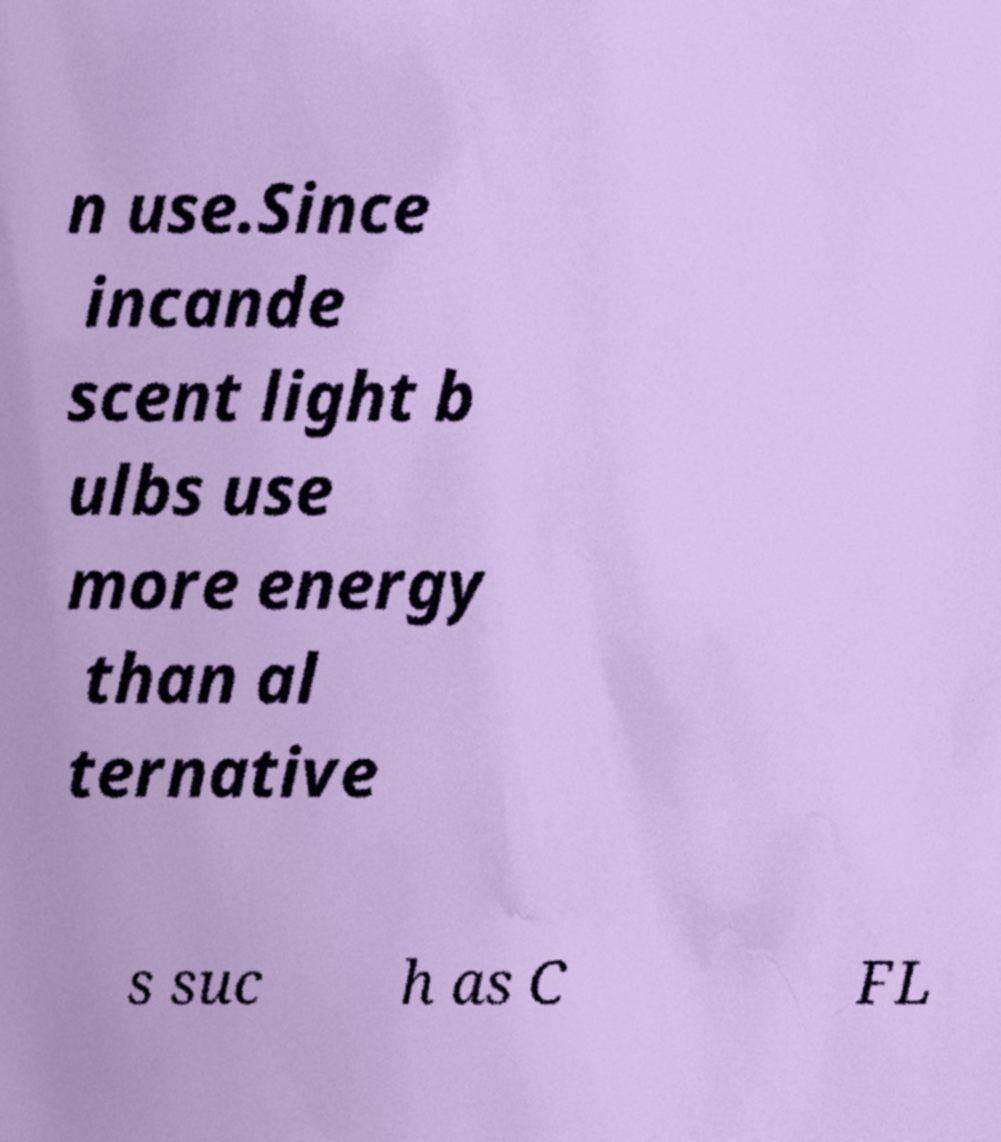Please identify and transcribe the text found in this image. n use.Since incande scent light b ulbs use more energy than al ternative s suc h as C FL 